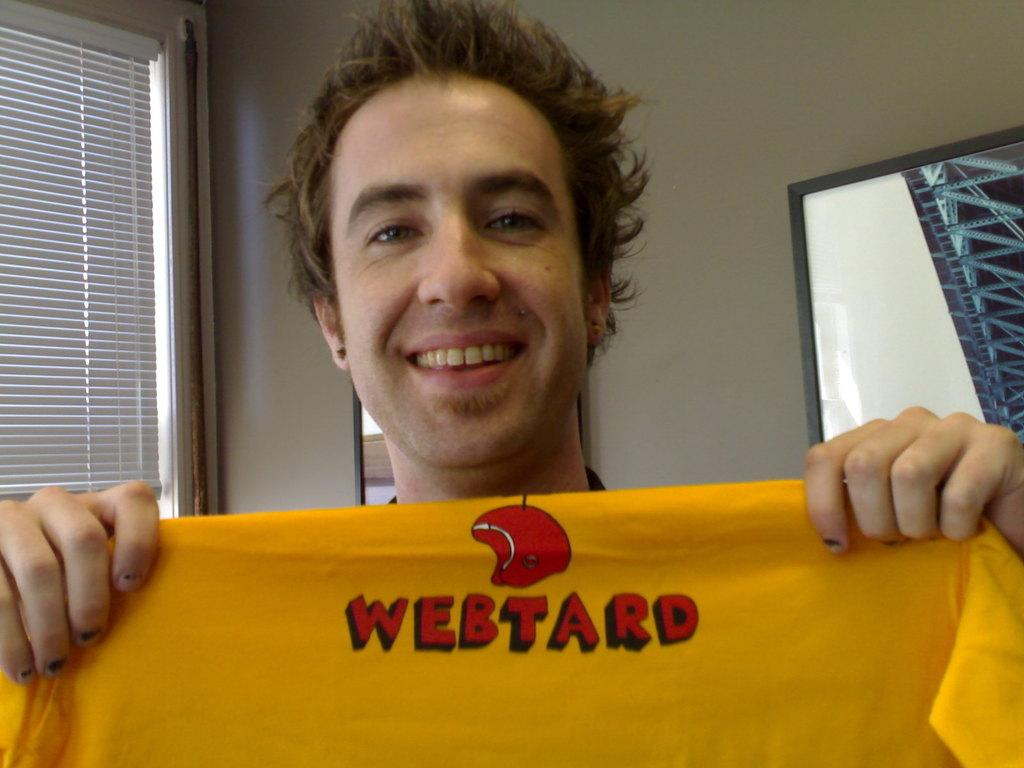What is the main subject of the image? There is a man in the image. What is the man holding in his hand? The man is holding a cloth in his hand. What can be seen behind the man? There is a wall behind the man. What object is present on the left side of the image? There is a mirror on the left side of the image. What type of notebook is the man using to take notes in the image? There is no notebook present in the image; the man is holding a cloth in his hand. Can you see a nest in the image? There is no nest present in the image. 